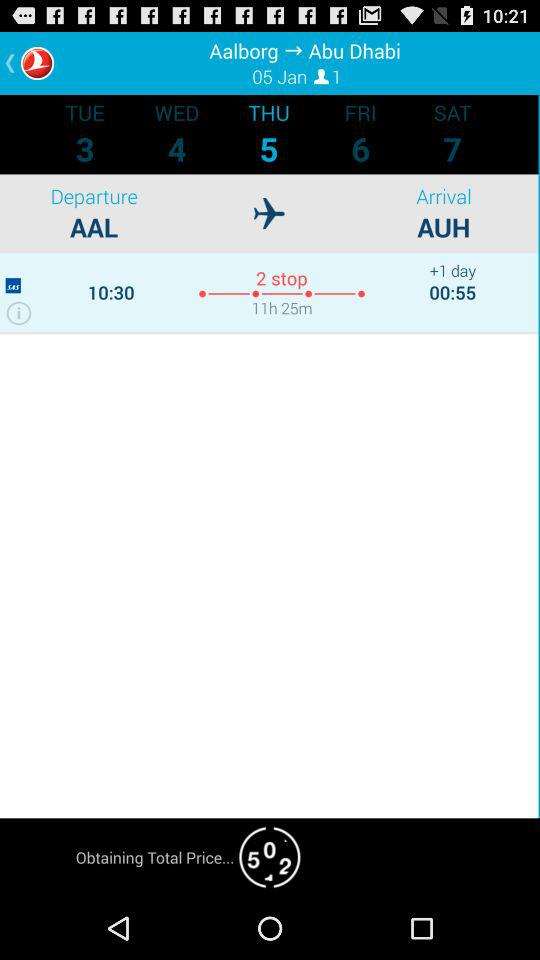What is the arrival location? The arrival location is Abu Dhabi. 